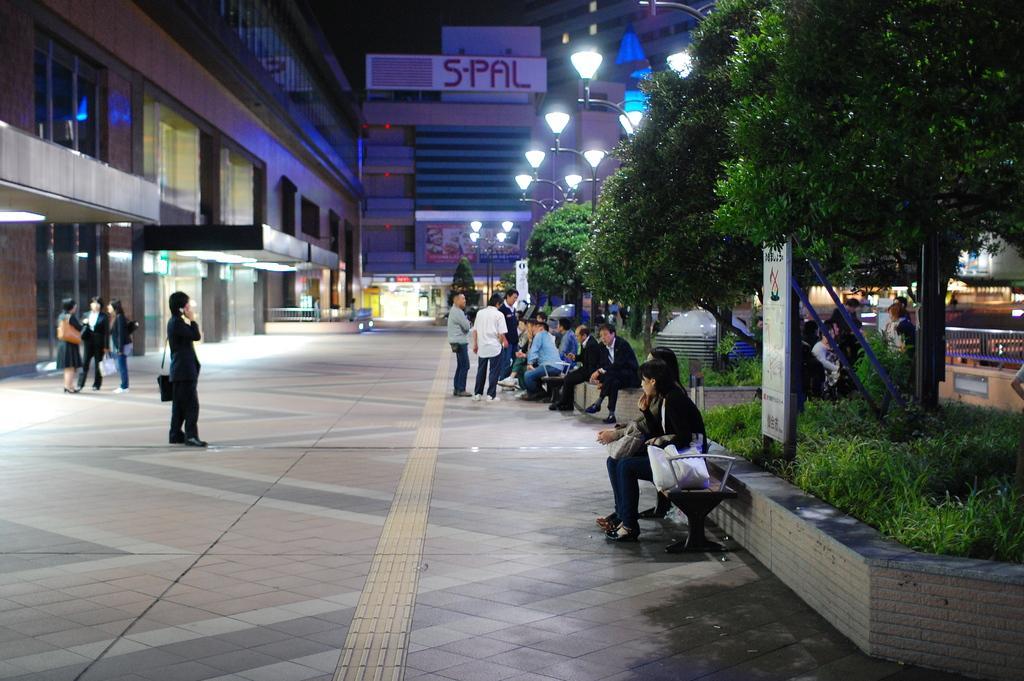Describe this image in one or two sentences. In this picture we can see some people are sitting and some people are standing. On the left side of the people there are buildings and on the right side of the people there is a board, grass, trees, iron grilles and poles with lights. Behind the people they are looking like hoardings which are attached to the building. 